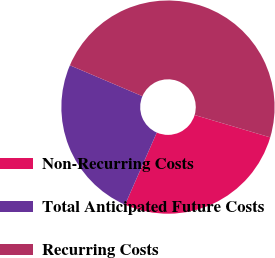Convert chart to OTSL. <chart><loc_0><loc_0><loc_500><loc_500><pie_chart><fcel>Non-Recurring Costs<fcel>Total Anticipated Future Costs<fcel>Recurring Costs<nl><fcel>27.01%<fcel>24.82%<fcel>48.17%<nl></chart> 